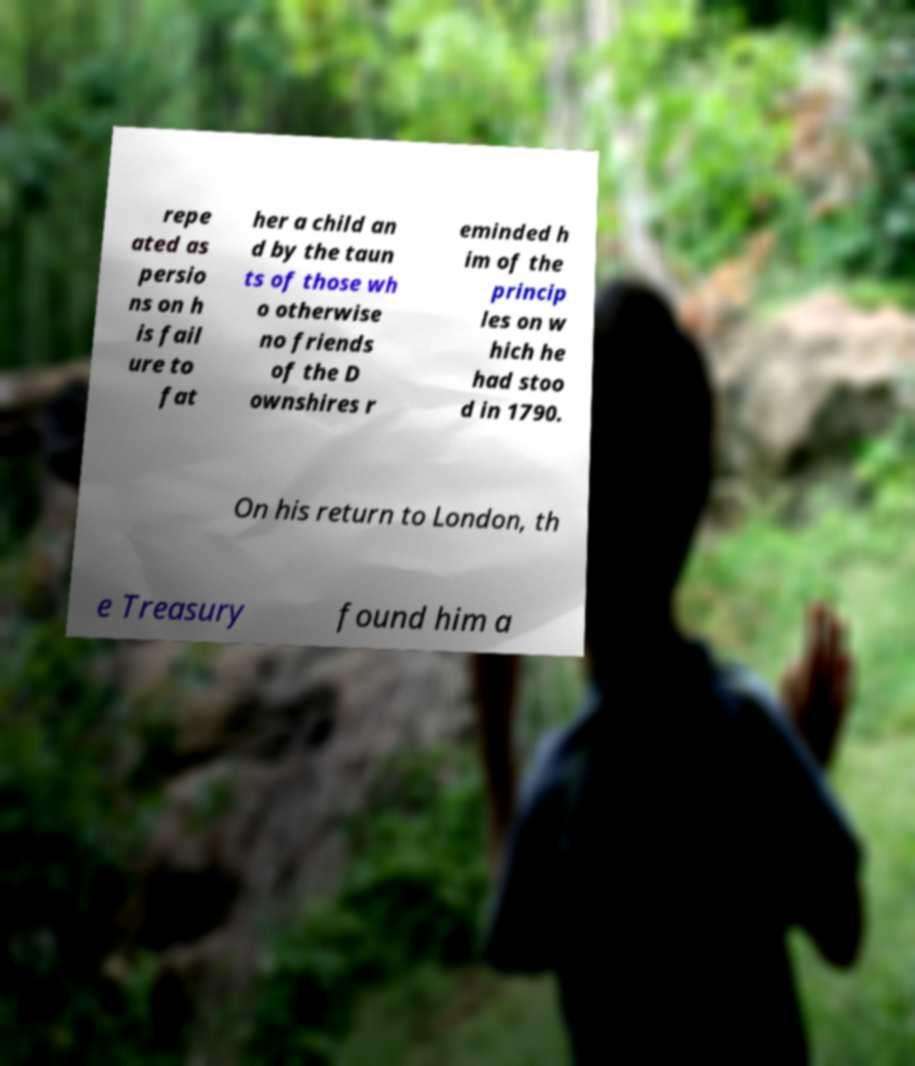Could you extract and type out the text from this image? repe ated as persio ns on h is fail ure to fat her a child an d by the taun ts of those wh o otherwise no friends of the D ownshires r eminded h im of the princip les on w hich he had stoo d in 1790. On his return to London, th e Treasury found him a 